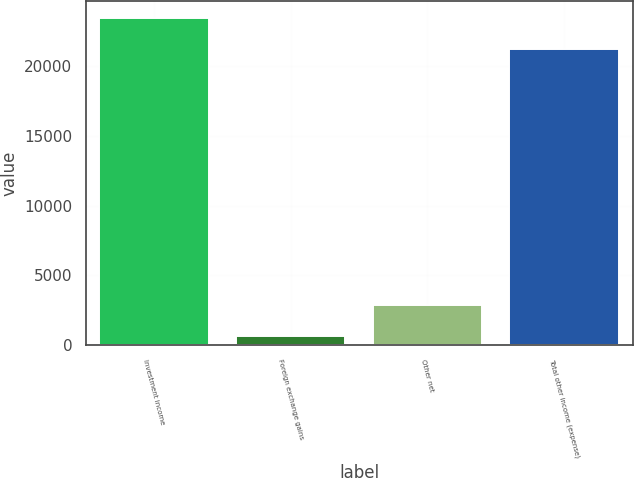Convert chart to OTSL. <chart><loc_0><loc_0><loc_500><loc_500><bar_chart><fcel>Investment income<fcel>Foreign exchange gains<fcel>Other net<fcel>Total other income (expense)<nl><fcel>23467.7<fcel>635<fcel>2889.7<fcel>21213<nl></chart> 